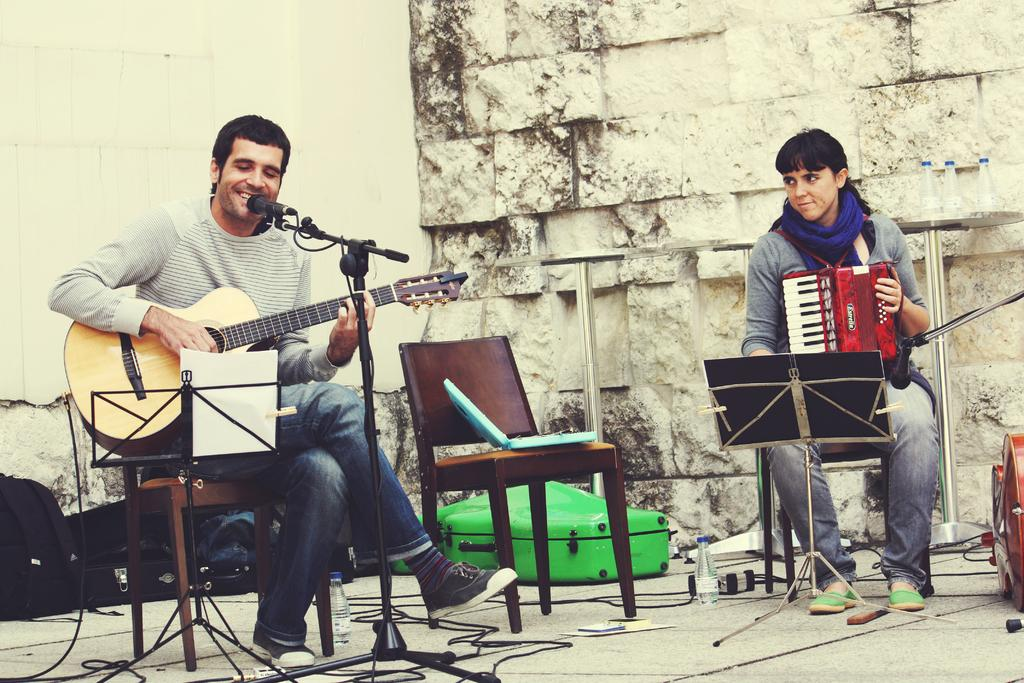How many people are in the image? There are two people in the image. What are the people doing in the image? One person is playing a guitar, and another person is playing a piano. What object is present in front of the people? There is a microphone in front of them. What type of jelly is being used as a sound amplifier for the piano in the image? There is no jelly present in the image, and the piano is not using any sound amplifier. 